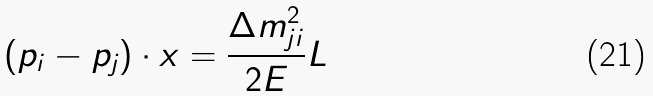<formula> <loc_0><loc_0><loc_500><loc_500>( p _ { i } - p _ { j } ) \cdot x = \frac { \Delta m _ { j i } ^ { 2 } } { 2 E } L</formula> 